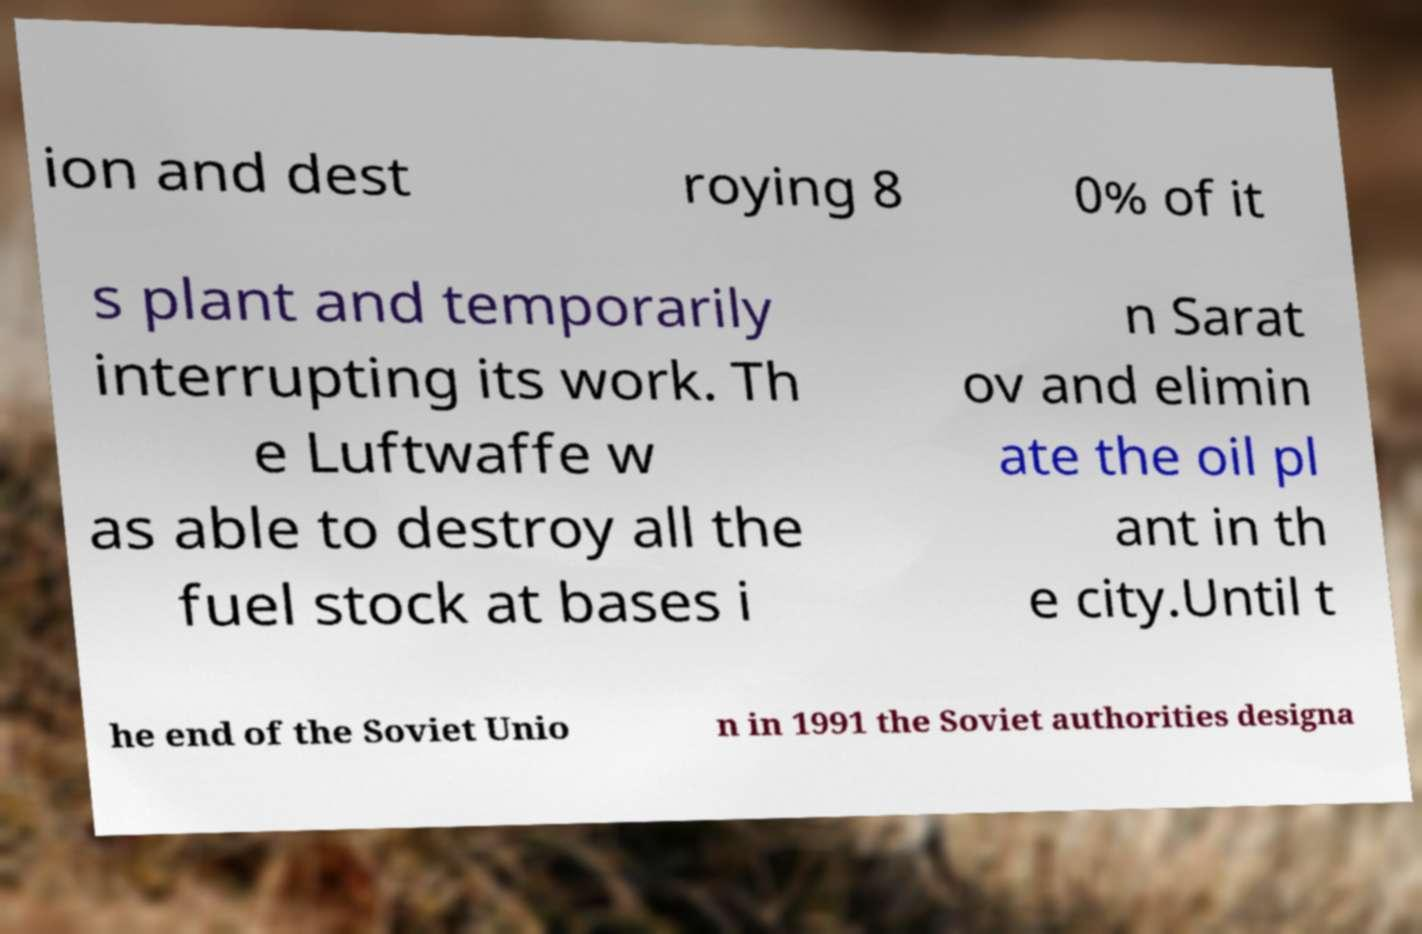Could you extract and type out the text from this image? ion and dest roying 8 0% of it s plant and temporarily interrupting its work. Th e Luftwaffe w as able to destroy all the fuel stock at bases i n Sarat ov and elimin ate the oil pl ant in th e city.Until t he end of the Soviet Unio n in 1991 the Soviet authorities designa 